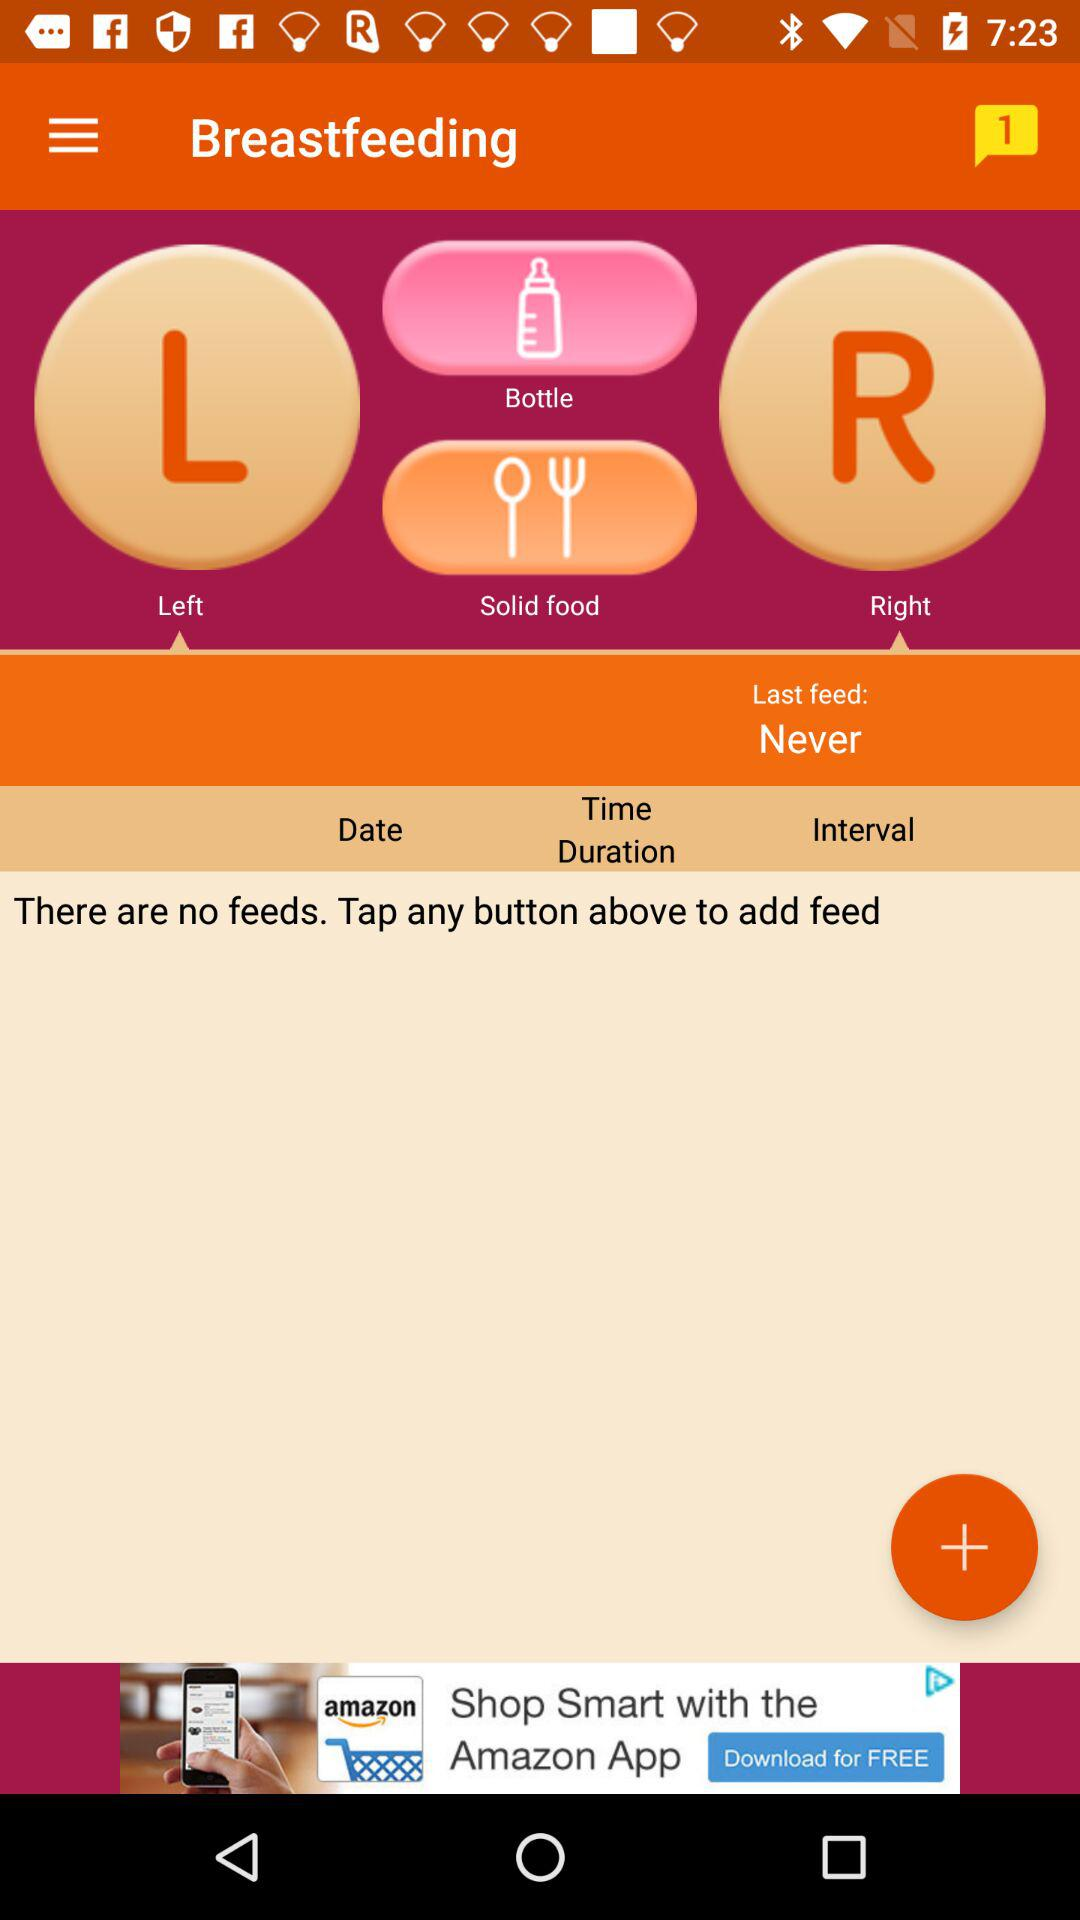What to do to add a feed? To add a feed, tap any button. 